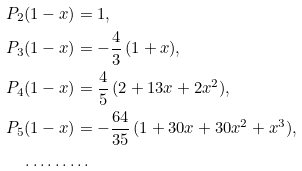<formula> <loc_0><loc_0><loc_500><loc_500>& P _ { 2 } ( 1 - x ) = 1 , \\ & P _ { 3 } ( 1 - x ) = - \frac { 4 } { 3 } \, ( 1 + x ) , \\ & P _ { 4 } ( 1 - x ) = \frac { 4 } { 5 } \, ( 2 + 1 3 x + 2 x ^ { 2 } ) , \\ & P _ { 5 } ( 1 - x ) = - \frac { 6 4 } { 3 5 } \, ( 1 + 3 0 x + 3 0 x ^ { 2 } + x ^ { 3 } ) , \\ & \quad \dots \dots \dots</formula> 